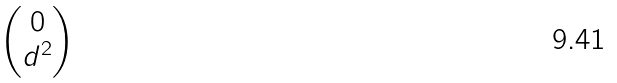Convert formula to latex. <formula><loc_0><loc_0><loc_500><loc_500>\begin{pmatrix} 0 \\ d ^ { 2 } \end{pmatrix}</formula> 